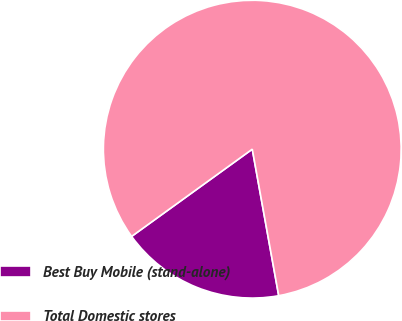Convert chart to OTSL. <chart><loc_0><loc_0><loc_500><loc_500><pie_chart><fcel>Best Buy Mobile (stand-alone)<fcel>Total Domestic stores<nl><fcel>17.88%<fcel>82.12%<nl></chart> 